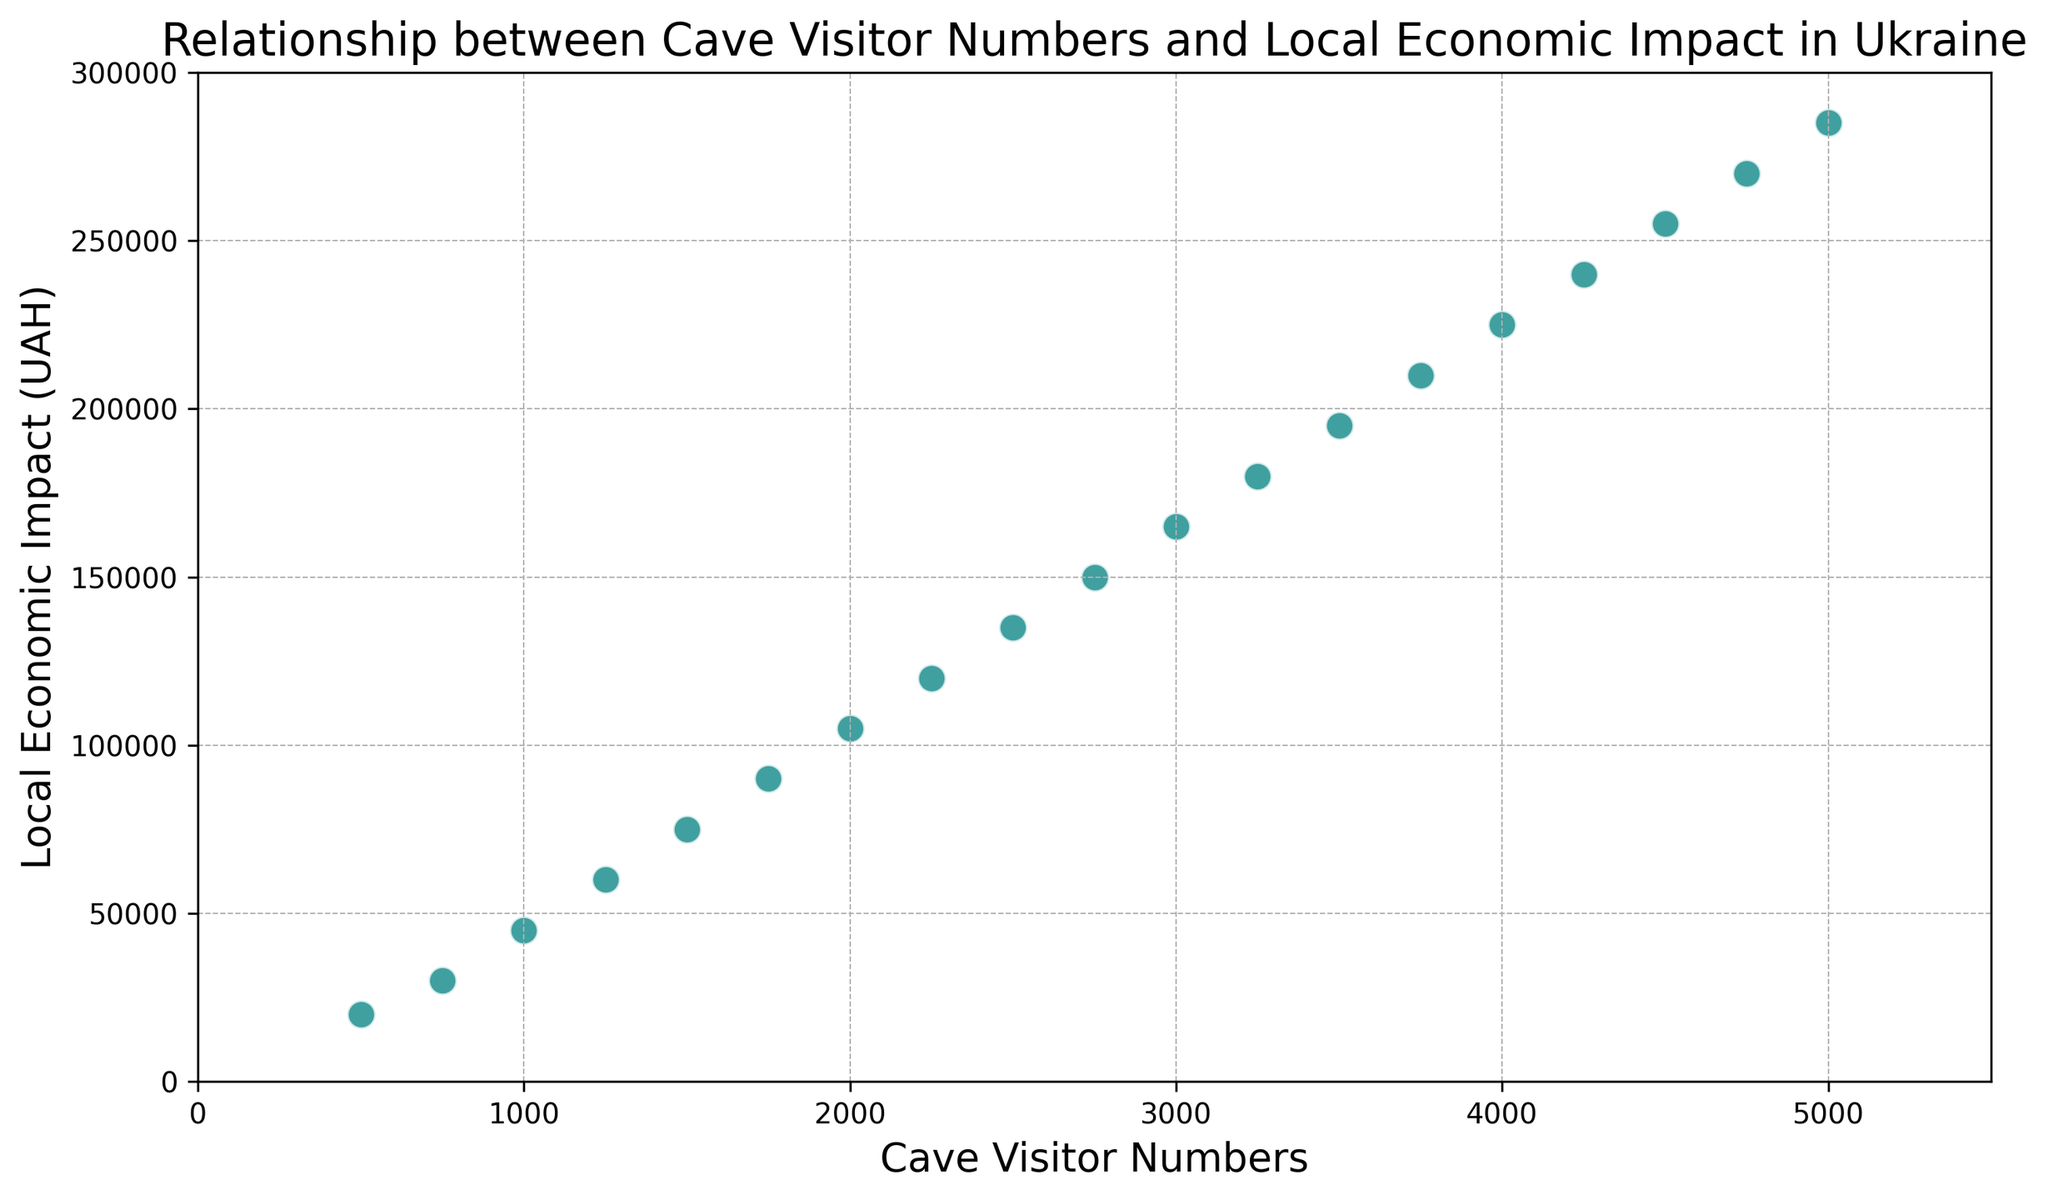What's the economic impact when there are 2500 cave visitors? Locate the data point corresponding to 2500 cave visitors on the x-axis and see where it aligns on the y-axis. Here, it aligns with 135,000 UAH.
Answer: 135,000 UAH How much greater is the economic impact with 4000 visitors compared to 1000 visitors? The economic impact for 4000 visitors is 225,000 UAH and for 1000 visitors is 45,000 UAH. Subtract the latter from the former: 225,000 - 45,000 = 180,000
Answer: 180,000 UAH By how much does the economic impact increase per 500 visitors on average between 1500 and 3000 visitors? From 1500 to 3000 visitors, the impact increases from 75,000 UAH to 165,000 UAH. This is an increase of 165,000 - 75,000 = 90,000 UAH for 1500 visitors. On average, 90,000 UAH / (3000 - 1500) * 500 = 30,000 UAH per 500 visitors.
Answer: 30,000 UAH Is the increase in local economic impact linear across the range of visitor numbers shown? Observe the scatter plot to see if the data points form a roughly straight line. A straight line indicates a linear relationship.
Answer: Yes What is the local economic impact when the number of cave visitors is the maximum value on the chart? Identify the maximum value on the x-axis (5000) and check the corresponding value on the y-axis, which is 285,000 UAH.
Answer: 285,000 UAH Between 2250 and 3500 visitors, which visitor number results in a higher economic impact? Locate the data points for 2250 and 3500 visitors on the x-axis and compare their y-axis values. 2250 visitors result in 120,000 UAH while 3500 visitors result in 195,000 UAH.
Answer: 3500 visitors What is the average local economic impact given the number of visitors is between 1000 and 2000? The data points for visitor numbers 1000, 1250, 1500, 1750, and 2000 correspond to economic impacts 45,000, 60,000, 75,000, 90,000, and 105,000 respectively. The average is (45,000 + 60,000 + 75,000 + 90,000 + 105,000)/5 = 75,000.
Answer: 75,000 UAH How does the color used in the scatter plot enhance understanding of the relationship between cave visitors and economic impact? The color teal with white edges and medium size enhances visibility and distinguishes each point clearly, making the relationship easier to interpret.
Answer: Enhances clarity and distinction Does the chart suggest any particular trend in economic impact with increasing visitor numbers? The general upward trend in the points suggests that local economic impact increases as the number of cave visitors increases.
Answer: Upward trend 